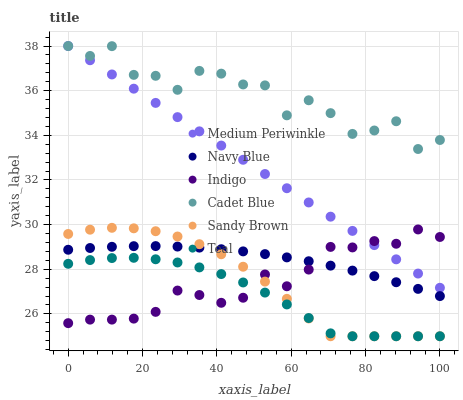Does Teal have the minimum area under the curve?
Answer yes or no. Yes. Does Cadet Blue have the maximum area under the curve?
Answer yes or no. Yes. Does Indigo have the minimum area under the curve?
Answer yes or no. No. Does Indigo have the maximum area under the curve?
Answer yes or no. No. Is Medium Periwinkle the smoothest?
Answer yes or no. Yes. Is Cadet Blue the roughest?
Answer yes or no. Yes. Is Indigo the smoothest?
Answer yes or no. No. Is Indigo the roughest?
Answer yes or no. No. Does Teal have the lowest value?
Answer yes or no. Yes. Does Indigo have the lowest value?
Answer yes or no. No. Does Medium Periwinkle have the highest value?
Answer yes or no. Yes. Does Indigo have the highest value?
Answer yes or no. No. Is Teal less than Cadet Blue?
Answer yes or no. Yes. Is Medium Periwinkle greater than Sandy Brown?
Answer yes or no. Yes. Does Indigo intersect Navy Blue?
Answer yes or no. Yes. Is Indigo less than Navy Blue?
Answer yes or no. No. Is Indigo greater than Navy Blue?
Answer yes or no. No. Does Teal intersect Cadet Blue?
Answer yes or no. No. 